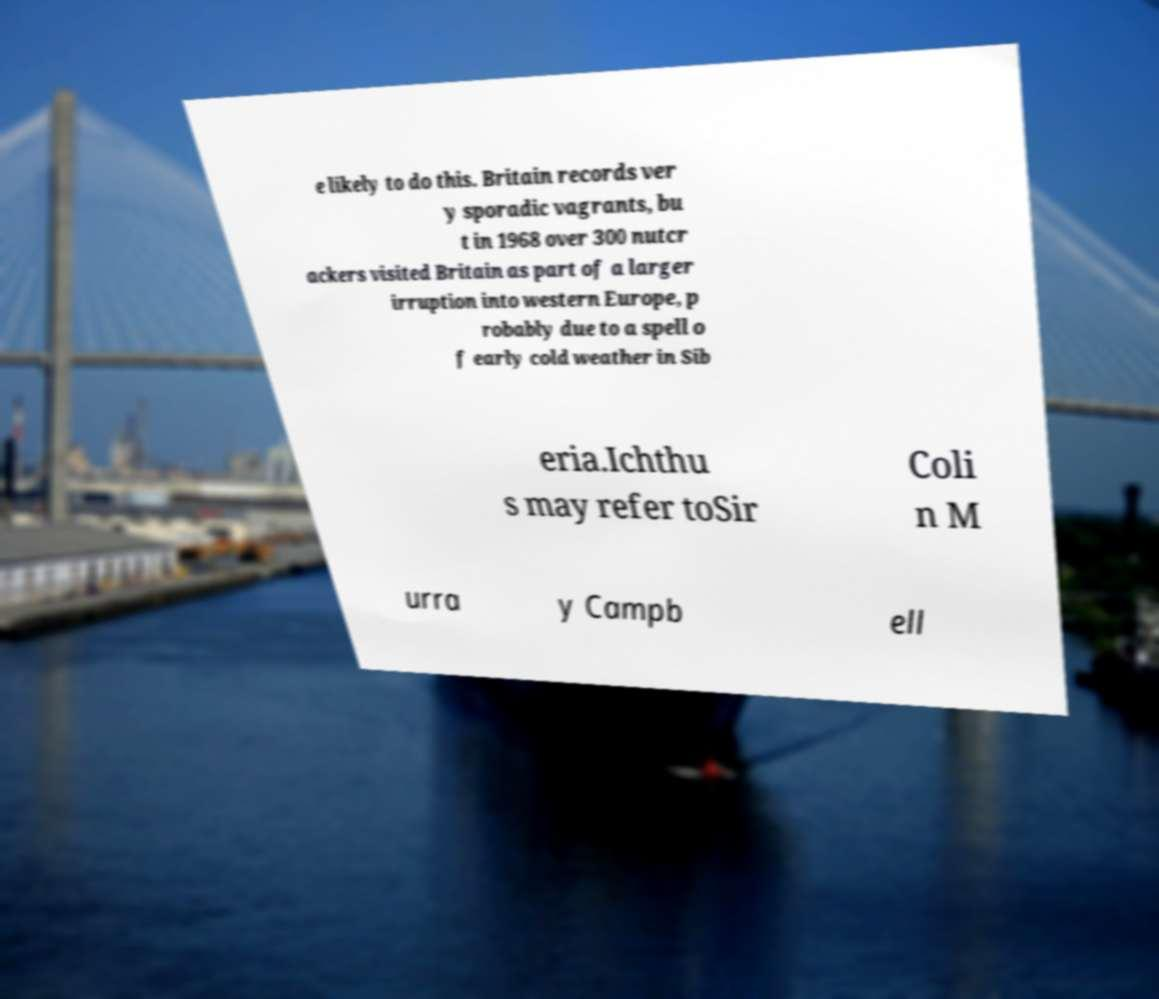I need the written content from this picture converted into text. Can you do that? e likely to do this. Britain records ver y sporadic vagrants, bu t in 1968 over 300 nutcr ackers visited Britain as part of a larger irruption into western Europe, p robably due to a spell o f early cold weather in Sib eria.Ichthu s may refer toSir Coli n M urra y Campb ell 